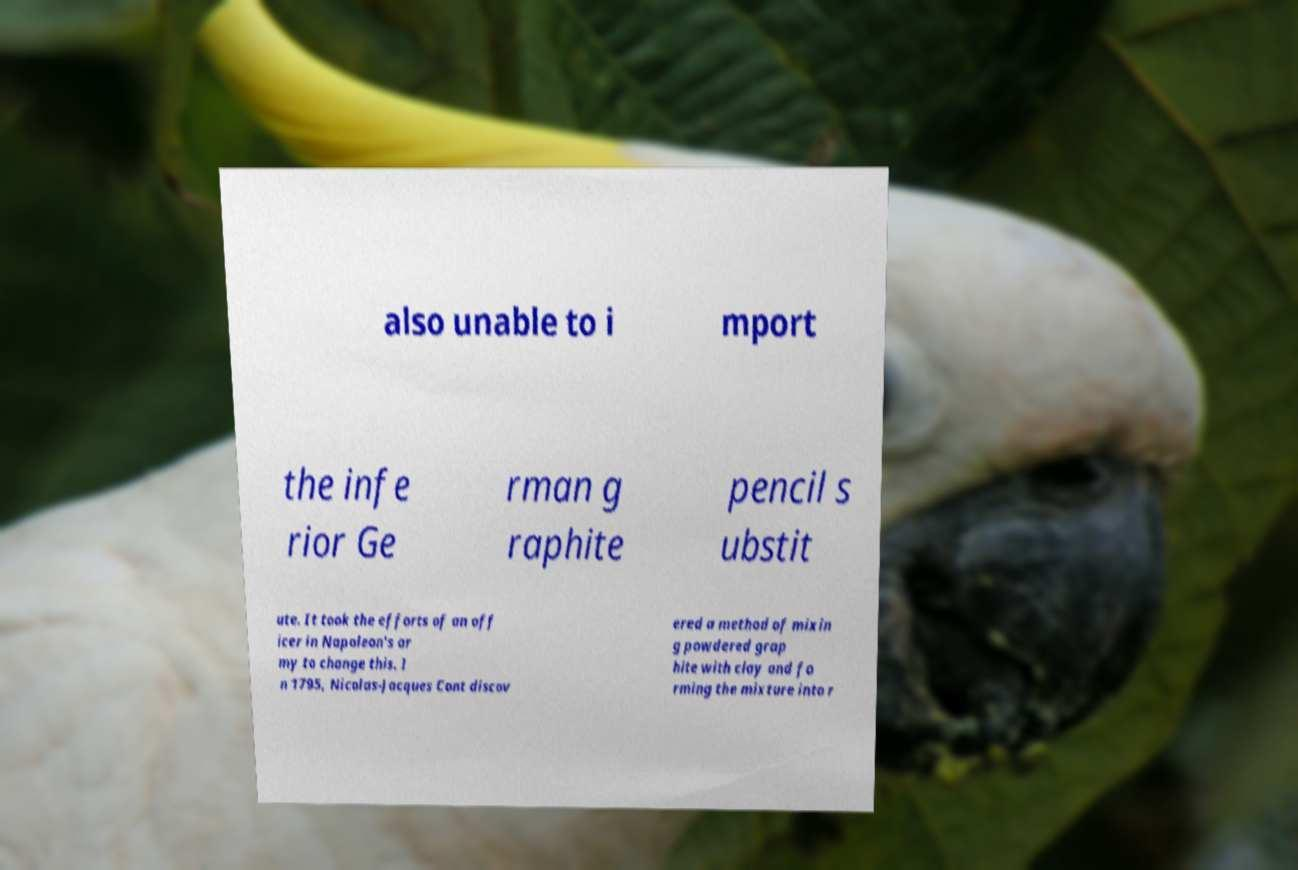Please identify and transcribe the text found in this image. also unable to i mport the infe rior Ge rman g raphite pencil s ubstit ute. It took the efforts of an off icer in Napoleon's ar my to change this. I n 1795, Nicolas-Jacques Cont discov ered a method of mixin g powdered grap hite with clay and fo rming the mixture into r 